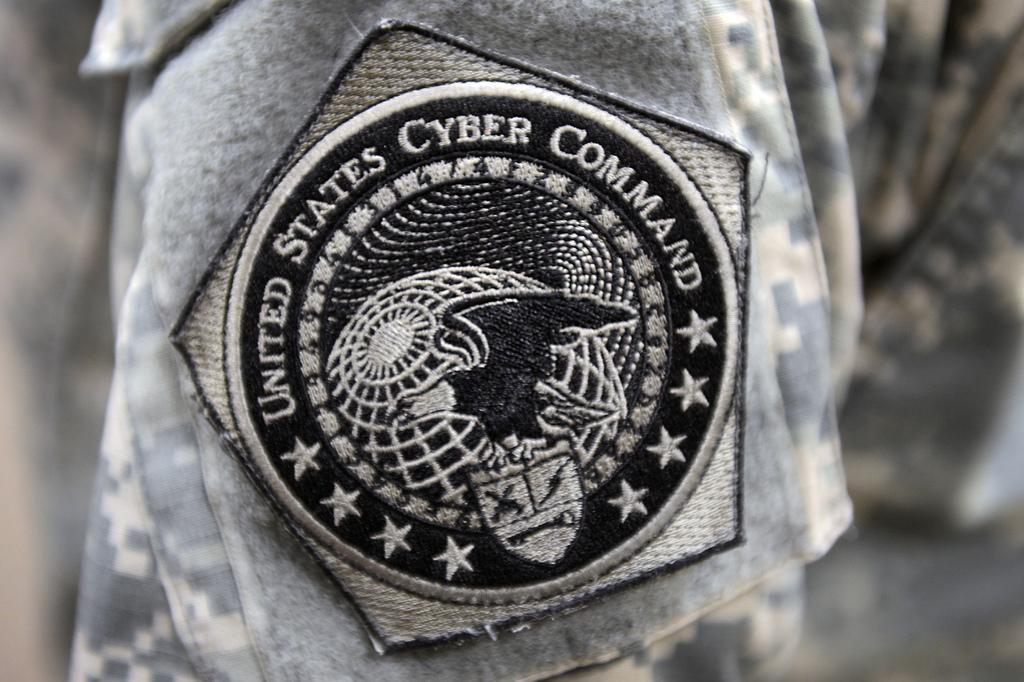What is present on the uniform in the image? There is a badge on the uniform in the image. What type of tin can be seen holding the letter in the image? There is no tin or letter present in the image; it only features a badge on a uniform. 